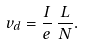Convert formula to latex. <formula><loc_0><loc_0><loc_500><loc_500>v _ { d } = \frac { I } { e } \, \frac { L } { N } .</formula> 